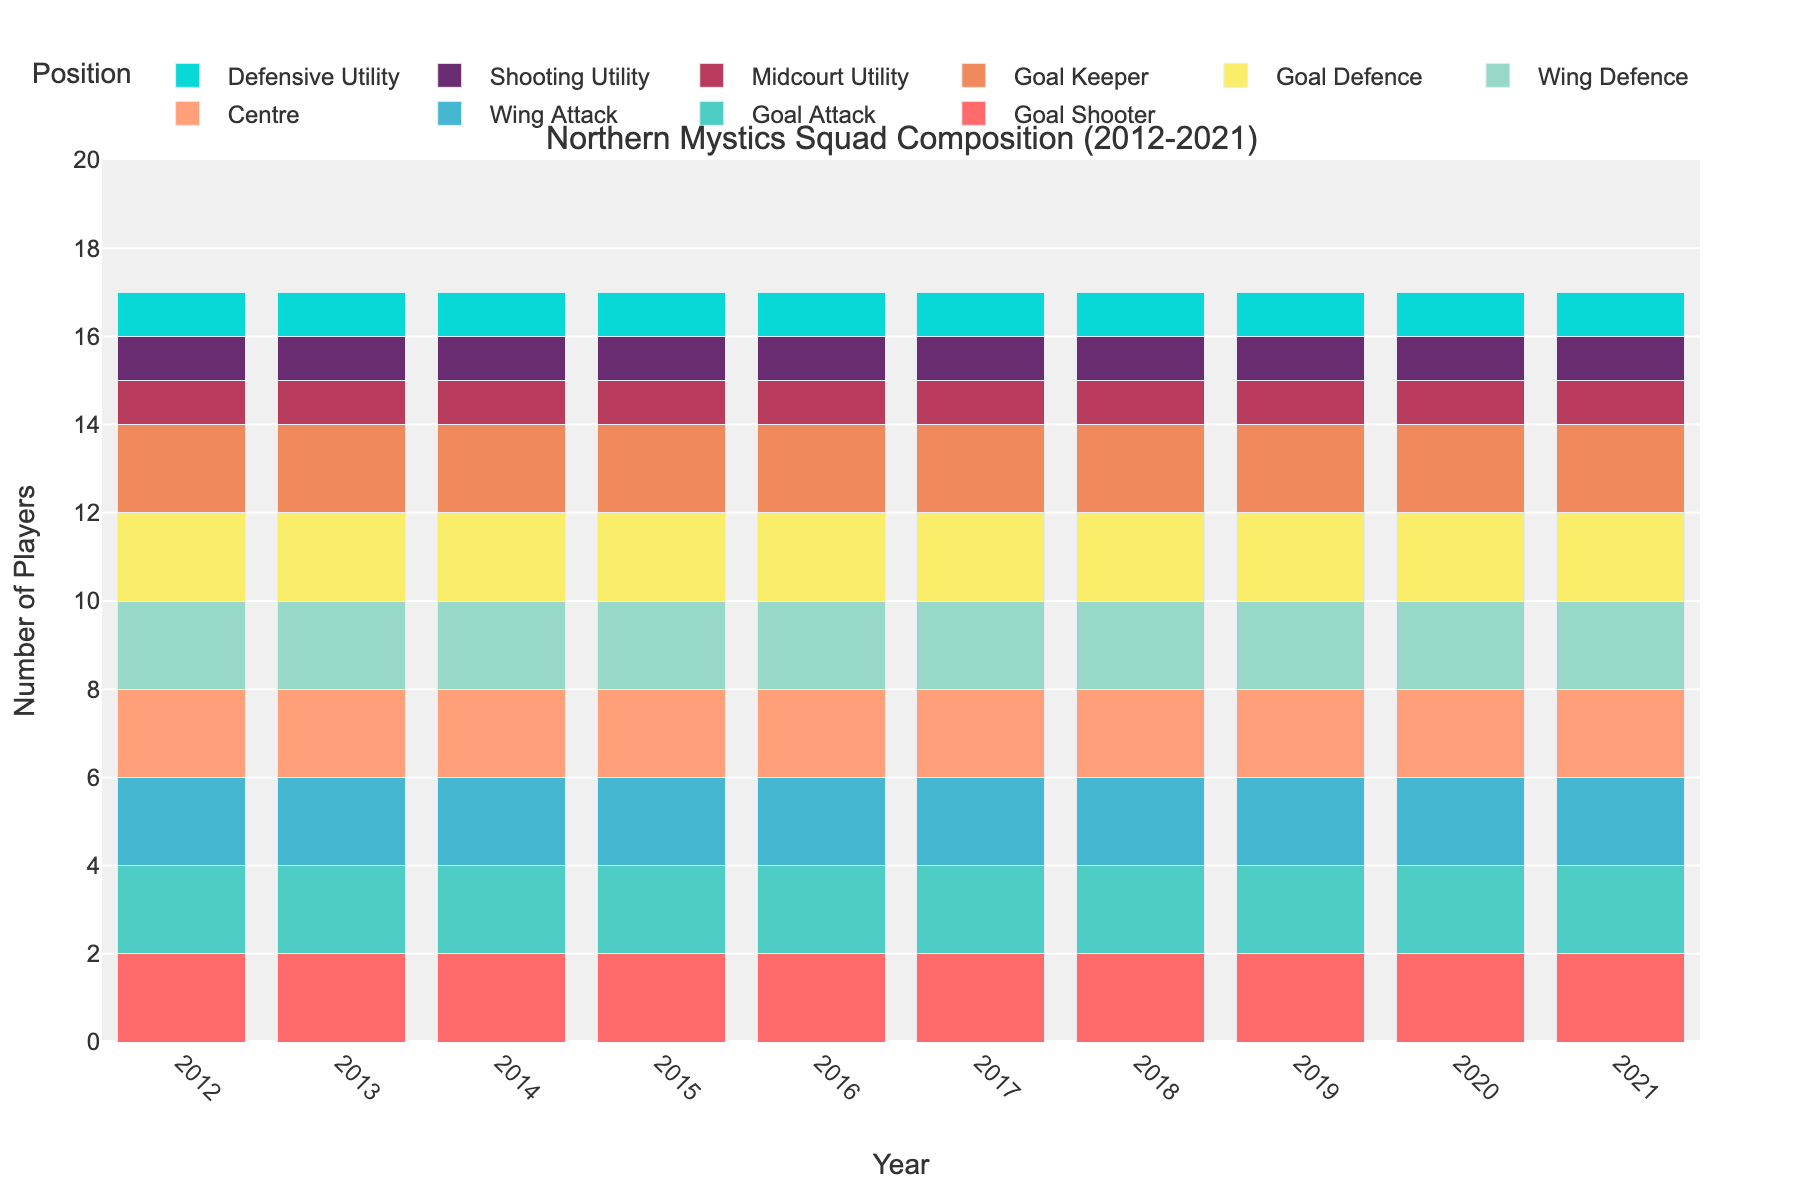What are the total number of 'Goal Shooter' and 'Goal Keeper' players every year? Add the number of 'Goal Shooter' and 'Goal Keeper' players for any given year. For instance, in 2021, 'Goal Shooter' has 2 players and 'Goal Keeper' has 2 players. Therefore, for 2021, the total is 2+2 = 4. Repeat this for each year.
Answer: 4 Which position has the highest number of players throughout the decade? Each position except for 'Midcourt Utility', 'Shooting Utility', and 'Defensive Utility' has 2 players consistently every year, which is higher than the 1 player in the remaining positions.
Answer: Goal Shooter, Goal Attack, Wing Attack, Centre, Wing Defence, Goal Defence, Goal Keeper (all have 2 players) Is the number of 'Midcourt Utility' players smaller than the number of 'Wing Attack' players in any year? Compare the number of players for 'Midcourt Utility' and 'Wing Attack' for any given year. 'Midcourt Utility' consistently has 1 player, while 'Wing Attack' has 2 players each year.
Answer: Yes What are the different positions that have exactly 2 players every year? Identify all positions with 2 players in any given year by observing the counts in the visual. These positions are comprised of 'Goal Shooter', 'Goal Attack', 'Wing Attack', 'Centre', 'Wing Defence', 'Goal Defence', and 'Goal Keeper'.
Answer: Goal Shooter, Goal Attack, Wing Attack, Centre, Wing Defence, Goal Defence, Goal Keeper How many players in total did the Northern Mystics field in their squad each year? Sum up the number of players across all positions for any given year. For any given year, the total players will be the sum across all positions (2+2+2+2+2+2+2+1+1+1), which sums to 17.
Answer: 17 What is the total number of 'Utility' players in 2015? Add the number of players in 'Midcourt Utility', 'Shooting Utility', and 'Defensive Utility' for 2015. Specifically, 1 ('Midcourt Utility') + 1 ('Shooting Utility') + 1 ('Defensive Utility') = 3.
Answer: 3 Was there any change in the number of players for any position over the decade? Verify the counts for each position from 2012 to 2021. All positions maintain their player counts throughout the years without any variations.
Answer: No 